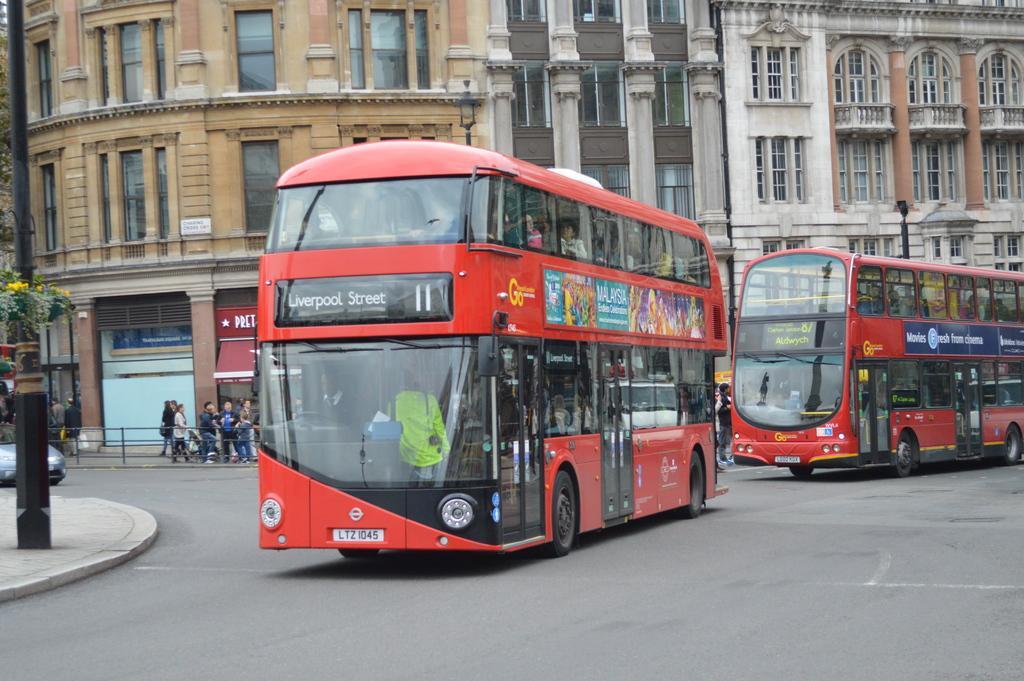Please provide a concise description of this image. In this image in the center there are two buses, and in the background there are some people walking. And there is a railing and on the left side there is a car, pole, plants and flowers. And in the background there are buildings. 